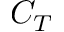<formula> <loc_0><loc_0><loc_500><loc_500>C _ { T }</formula> 